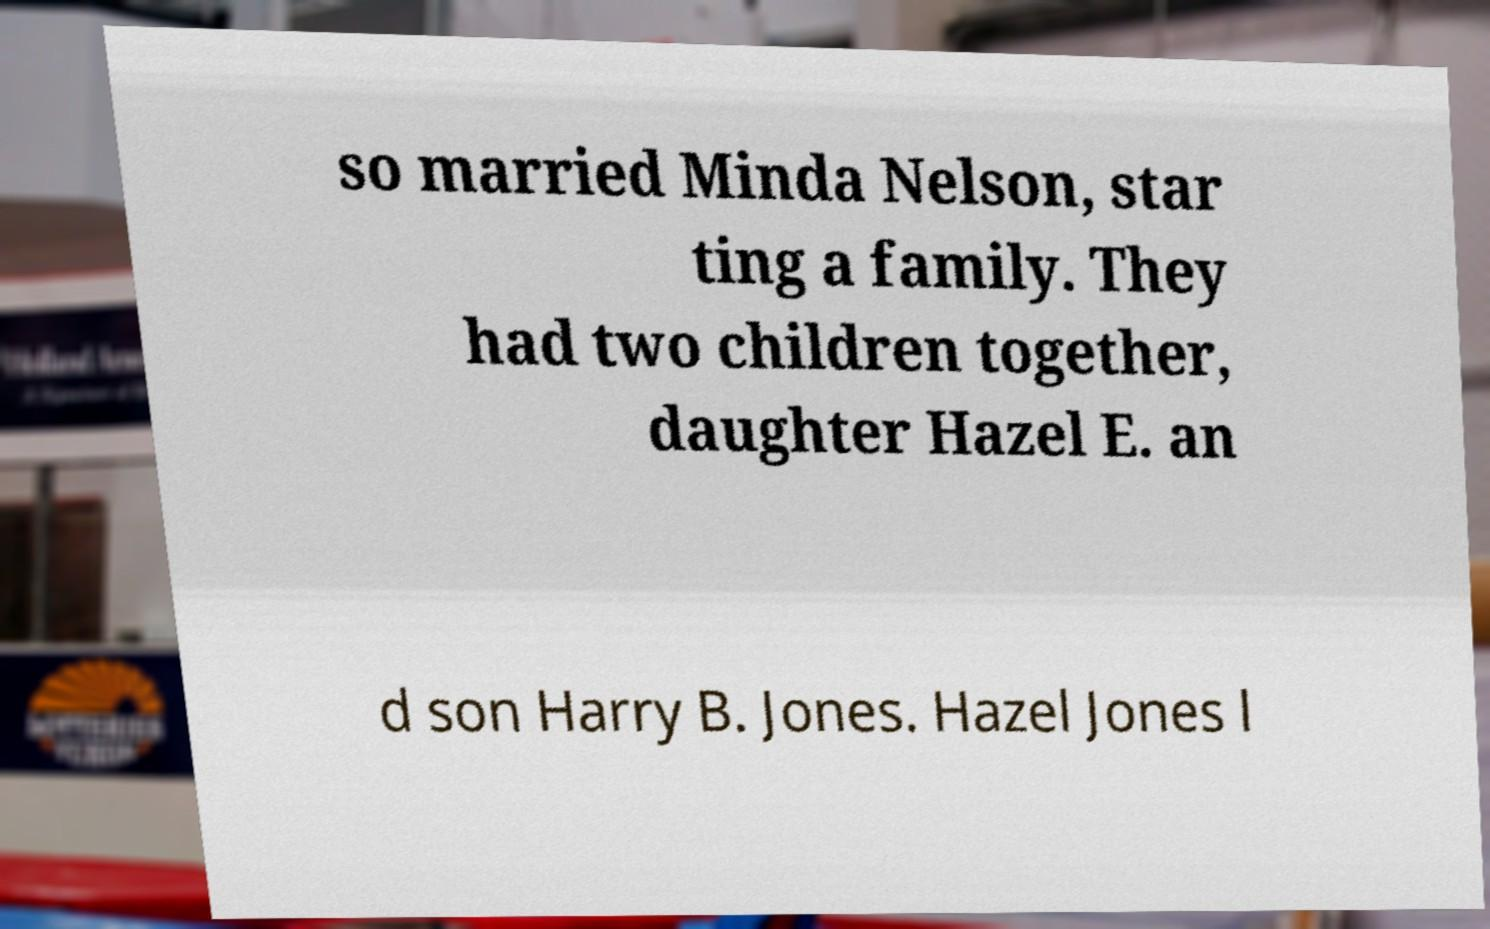Can you accurately transcribe the text from the provided image for me? so married Minda Nelson, star ting a family. They had two children together, daughter Hazel E. an d son Harry B. Jones. Hazel Jones l 